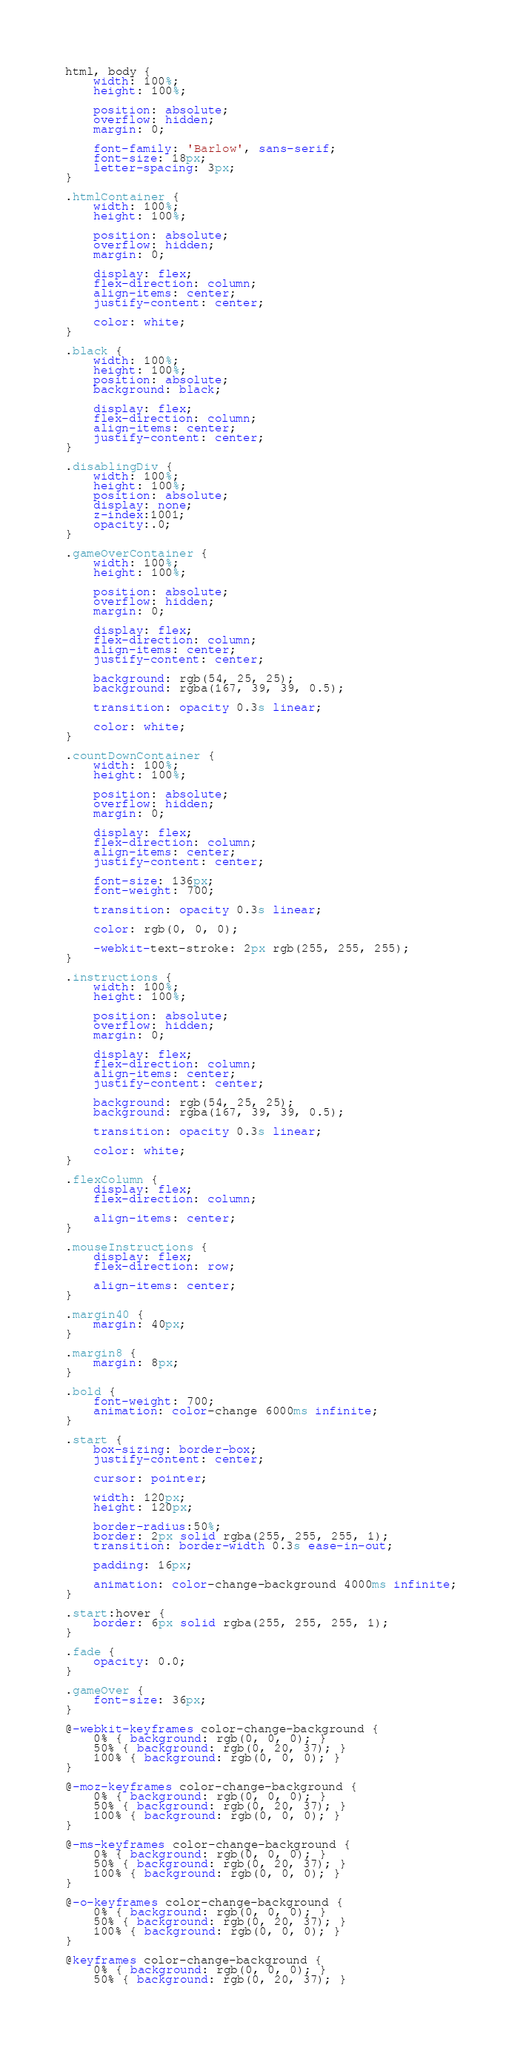Convert code to text. <code><loc_0><loc_0><loc_500><loc_500><_CSS_>html, body {
    width: 100%;
    height: 100%;
    
    position: absolute;
    overflow: hidden;
    margin: 0;

    font-family: 'Barlow', sans-serif;
    font-size: 18px;
    letter-spacing: 3px;
}

.htmlContainer {
    width: 100%;
    height: 100%;
    
    position: absolute;
    overflow: hidden;
    margin: 0;

    display: flex;
    flex-direction: column;
    align-items: center;
    justify-content: center;

    color: white;   
}

.black {
    width: 100%;
    height: 100%;
    position: absolute;
    background: black;

    display: flex;
    flex-direction: column;
    align-items: center;
    justify-content: center;
}

.disablingDiv {
    width: 100%;
    height: 100%;
    position: absolute;
    display: none; 
    z-index:1001;
    opacity:.0; 
}

.gameOverContainer {
    width: 100%;
    height: 100%;
    
    position: absolute;
    overflow: hidden;
    margin: 0;

    display: flex;
    flex-direction: column;
    align-items: center;
    justify-content: center;
    
    background: rgb(54, 25, 25);
    background: rgba(167, 39, 39, 0.5);

    transition: opacity 0.3s linear;

    color: white;   
}

.countDownContainer {
    width: 100%;
    height: 100%;
    
    position: absolute;
    overflow: hidden;
    margin: 0;

    display: flex;
    flex-direction: column;
    align-items: center;
    justify-content: center;

    font-size: 136px;
    font-weight: 700;

    transition: opacity 0.3s linear;

    color: rgb(0, 0, 0);   

    -webkit-text-stroke: 2px rgb(255, 255, 255);
}

.instructions {
    width: 100%;
    height: 100%;
    
    position: absolute;
    overflow: hidden;
    margin: 0;

    display: flex;
    flex-direction: column;
    align-items: center;
    justify-content: center;
    
    background: rgb(54, 25, 25);
    background: rgba(167, 39, 39, 0.5);

    transition: opacity 0.3s linear;

    color: white;   
}

.flexColumn {
    display: flex;
    flex-direction: column;

    align-items: center;
}

.mouseInstructions {
    display: flex;
    flex-direction: row;

    align-items: center;
}

.margin40 {
    margin: 40px;
}

.margin8 {
    margin: 8px;
}

.bold {
    font-weight: 700;    
    animation: color-change 6000ms infinite;
}

.start {
    box-sizing: border-box;
    justify-content: center;

    cursor: pointer;

    width: 120px;
    height: 120px;
    
    border-radius:50%;
    border: 2px solid rgba(255, 255, 255, 1);
    transition: border-width 0.3s ease-in-out;

    padding: 16px;

    animation: color-change-background 4000ms infinite;
}

.start:hover {
    border: 6px solid rgba(255, 255, 255, 1);
}

.fade {
    opacity: 0.0;
}

.gameOver {
    font-size: 36px;
}

@-webkit-keyframes color-change-background {
    0% { background: rgb(0, 0, 0); }
    50% { background: rgb(0, 20, 37); }
    100% { background: rgb(0, 0, 0); }
}

@-moz-keyframes color-change-background {
    0% { background: rgb(0, 0, 0); }
    50% { background: rgb(0, 20, 37); }
    100% { background: rgb(0, 0, 0); }
}

@-ms-keyframes color-change-background {
    0% { background: rgb(0, 0, 0); }
    50% { background: rgb(0, 20, 37); }
    100% { background: rgb(0, 0, 0); }
}

@-o-keyframes color-change-background {
    0% { background: rgb(0, 0, 0); }
    50% { background: rgb(0, 20, 37); }
    100% { background: rgb(0, 0, 0); }
}

@keyframes color-change-background {
    0% { background: rgb(0, 0, 0); }
    50% { background: rgb(0, 20, 37); }</code> 